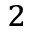Convert formula to latex. <formula><loc_0><loc_0><loc_500><loc_500>^ { 2 }</formula> 